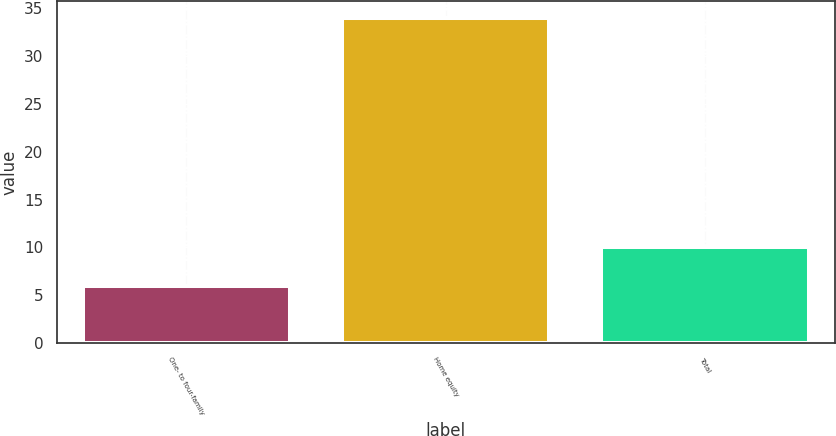<chart> <loc_0><loc_0><loc_500><loc_500><bar_chart><fcel>One- to four-family<fcel>Home equity<fcel>Total<nl><fcel>6<fcel>34<fcel>10<nl></chart> 